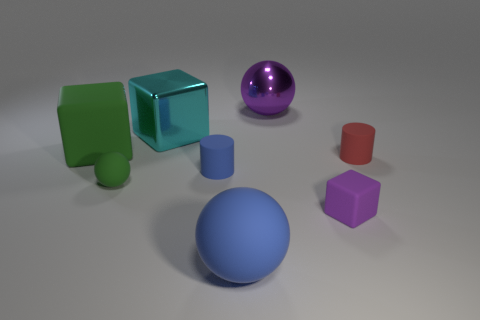There is a red thing on the right side of the green matte thing that is behind the tiny object that is behind the small blue matte thing; what is its size?
Your response must be concise. Small. Are there the same number of small matte blocks that are to the right of the green matte cube and tiny red cylinders that are in front of the cyan block?
Provide a short and direct response. Yes. There is a tiny purple thing that is the same shape as the large cyan thing; what is it made of?
Your answer should be compact. Rubber. There is a blue thing that is in front of the cube in front of the green rubber block; are there any large metal things that are on the right side of it?
Ensure brevity in your answer.  Yes. Is the shape of the metallic object that is in front of the large purple ball the same as the large rubber object that is in front of the small purple rubber thing?
Provide a succinct answer. No. Are there more tiny green balls that are on the right side of the large blue rubber ball than green objects?
Give a very brief answer. No. How many things are either tiny yellow blocks or matte spheres?
Give a very brief answer. 2. What is the color of the large rubber ball?
Provide a succinct answer. Blue. How many other objects are there of the same color as the large shiny sphere?
Make the answer very short. 1. Are there any tiny red matte things on the left side of the big blue matte sphere?
Provide a succinct answer. No. 